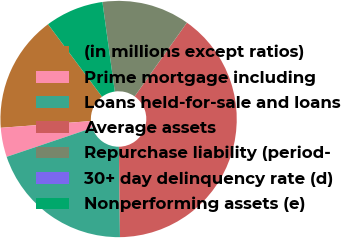Convert chart to OTSL. <chart><loc_0><loc_0><loc_500><loc_500><pie_chart><fcel>(in millions except ratios)<fcel>Prime mortgage including<fcel>Loans held-for-sale and loans<fcel>Average assets<fcel>Repurchase liability (period-<fcel>30+ day delinquency rate (d)<fcel>Nonperforming assets (e)<nl><fcel>16.0%<fcel>4.0%<fcel>20.0%<fcel>40.0%<fcel>12.0%<fcel>0.0%<fcel>8.0%<nl></chart> 